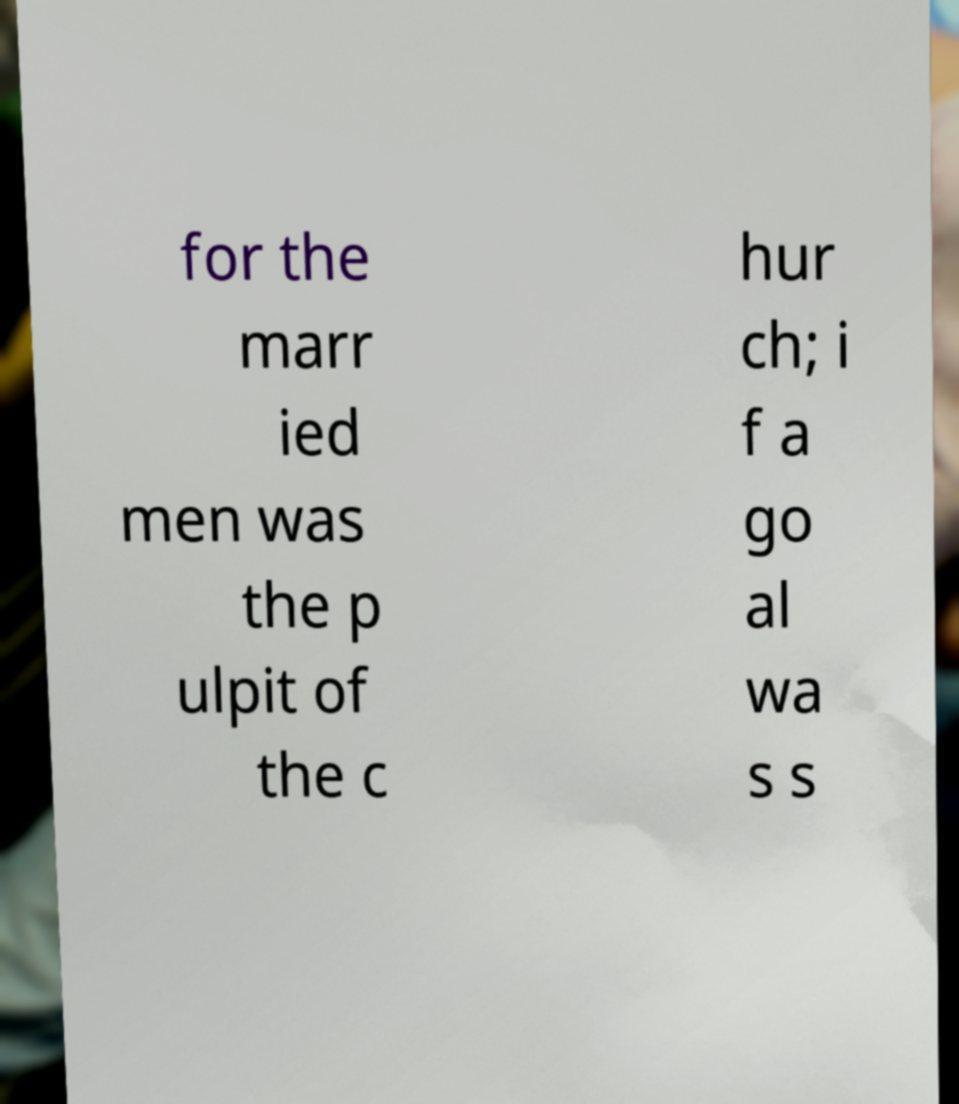Can you read and provide the text displayed in the image?This photo seems to have some interesting text. Can you extract and type it out for me? for the marr ied men was the p ulpit of the c hur ch; i f a go al wa s s 